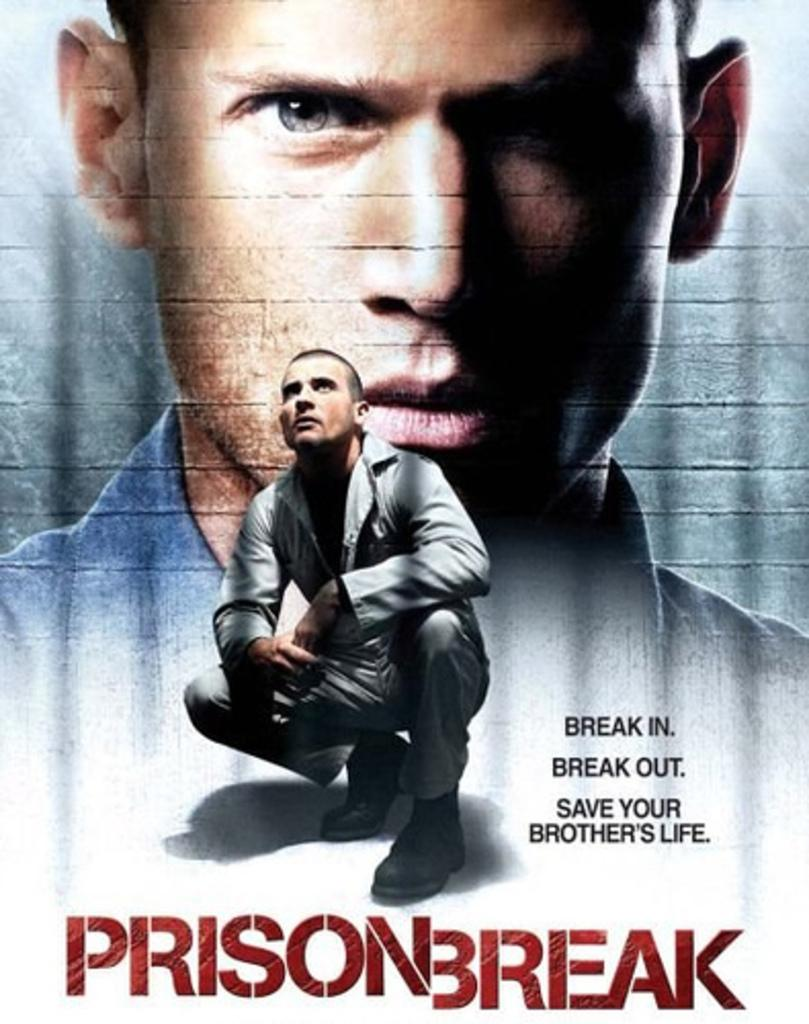<image>
Create a compact narrative representing the image presented. A movie poster titled prison break with an image of a man on it. 